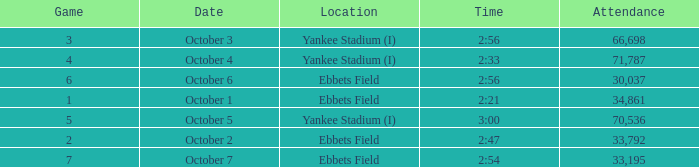Help me parse the entirety of this table. {'header': ['Game', 'Date', 'Location', 'Time', 'Attendance'], 'rows': [['3', 'October 3', 'Yankee Stadium (I)', '2:56', '66,698'], ['4', 'October 4', 'Yankee Stadium (I)', '2:33', '71,787'], ['6', 'October 6', 'Ebbets Field', '2:56', '30,037'], ['1', 'October 1', 'Ebbets Field', '2:21', '34,861'], ['5', 'October 5', 'Yankee Stadium (I)', '3:00', '70,536'], ['2', 'October 2', 'Ebbets Field', '2:47', '33,792'], ['7', 'October 7', 'Ebbets Field', '2:54', '33,195']]} Location of ebbets field, and a Time of 2:56, and a Game larger than 6 has what sum of attendance? None. 